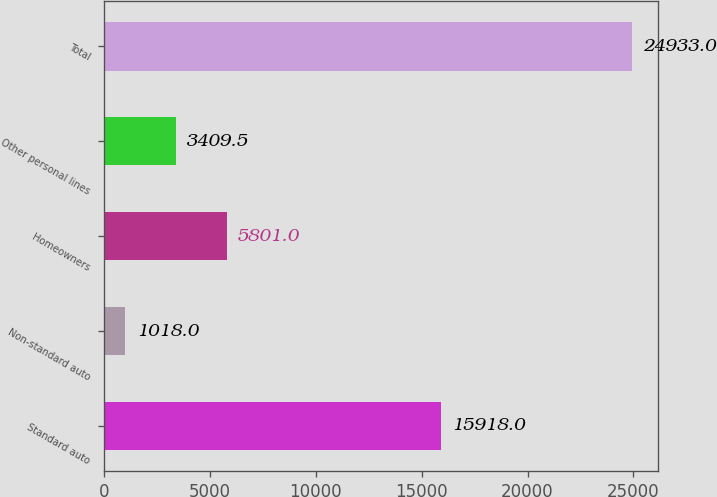<chart> <loc_0><loc_0><loc_500><loc_500><bar_chart><fcel>Standard auto<fcel>Non-standard auto<fcel>Homeowners<fcel>Other personal lines<fcel>Total<nl><fcel>15918<fcel>1018<fcel>5801<fcel>3409.5<fcel>24933<nl></chart> 